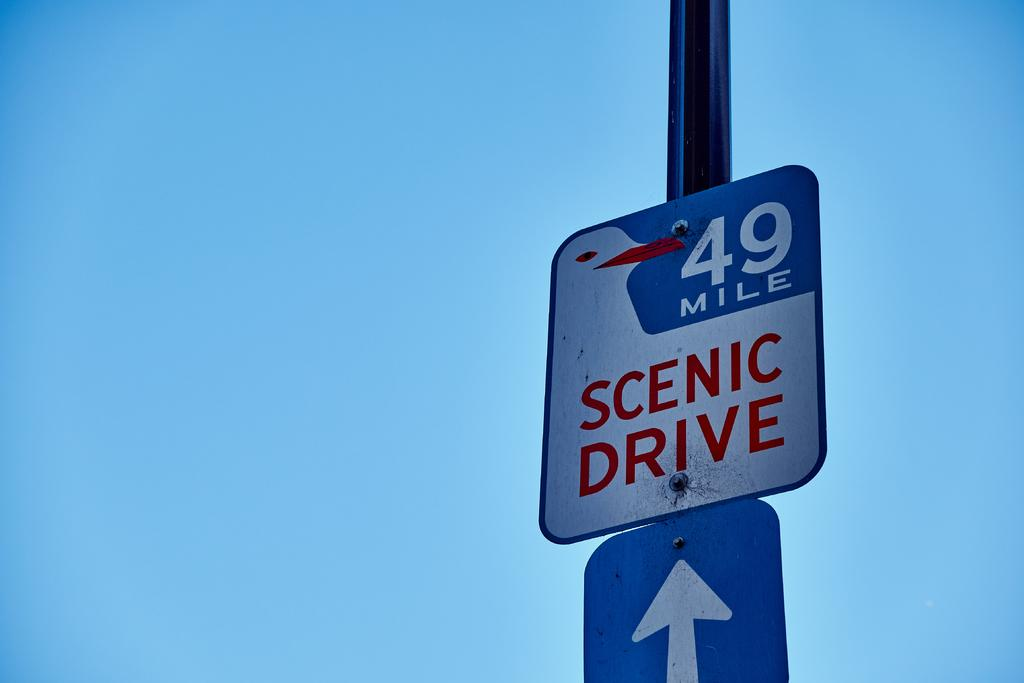What is the main object in the image? There is a pole in the image. What is attached to the pole? There is a board on the pole. What can be found on the board? The board has text and numbers written on it. What type of smell can be detected from the board in the image? There is no indication of a smell in the image, as it only shows a pole with a board containing text and numbers. 